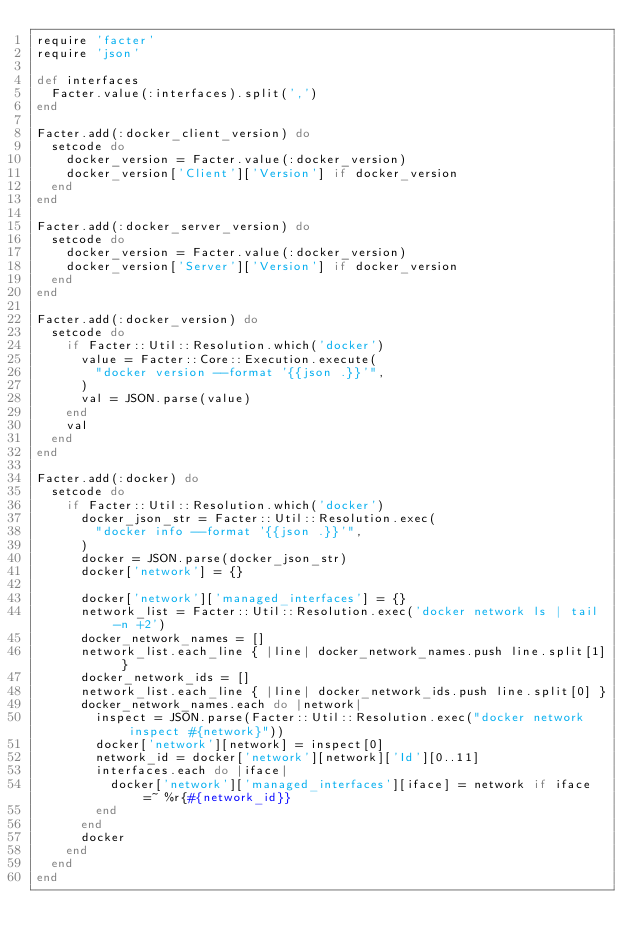Convert code to text. <code><loc_0><loc_0><loc_500><loc_500><_Ruby_>require 'facter'
require 'json'

def interfaces
  Facter.value(:interfaces).split(',')
end

Facter.add(:docker_client_version) do
  setcode do
    docker_version = Facter.value(:docker_version)
    docker_version['Client']['Version'] if docker_version
  end
end

Facter.add(:docker_server_version) do
  setcode do
    docker_version = Facter.value(:docker_version)
    docker_version['Server']['Version'] if docker_version
  end
end

Facter.add(:docker_version) do
  setcode do
    if Facter::Util::Resolution.which('docker')
      value = Facter::Core::Execution.execute(
        "docker version --format '{{json .}}'",
      )
      val = JSON.parse(value)
    end
    val
  end
end

Facter.add(:docker) do
  setcode do
    if Facter::Util::Resolution.which('docker')
      docker_json_str = Facter::Util::Resolution.exec(
        "docker info --format '{{json .}}'",
      )
      docker = JSON.parse(docker_json_str)
      docker['network'] = {}

      docker['network']['managed_interfaces'] = {}
      network_list = Facter::Util::Resolution.exec('docker network ls | tail -n +2')
      docker_network_names = []
      network_list.each_line { |line| docker_network_names.push line.split[1] }
      docker_network_ids = []
      network_list.each_line { |line| docker_network_ids.push line.split[0] }
      docker_network_names.each do |network|
        inspect = JSON.parse(Facter::Util::Resolution.exec("docker network inspect #{network}"))
        docker['network'][network] = inspect[0]
        network_id = docker['network'][network]['Id'][0..11]
        interfaces.each do |iface|
          docker['network']['managed_interfaces'][iface] = network if iface =~ %r{#{network_id}}
        end
      end
      docker
    end
  end
end
</code> 